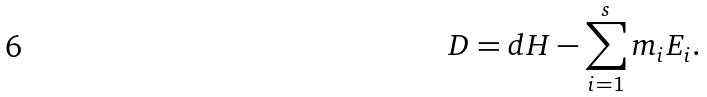Convert formula to latex. <formula><loc_0><loc_0><loc_500><loc_500>D = d H - \sum _ { i = 1 } ^ { s } m _ { i } E _ { i } .</formula> 